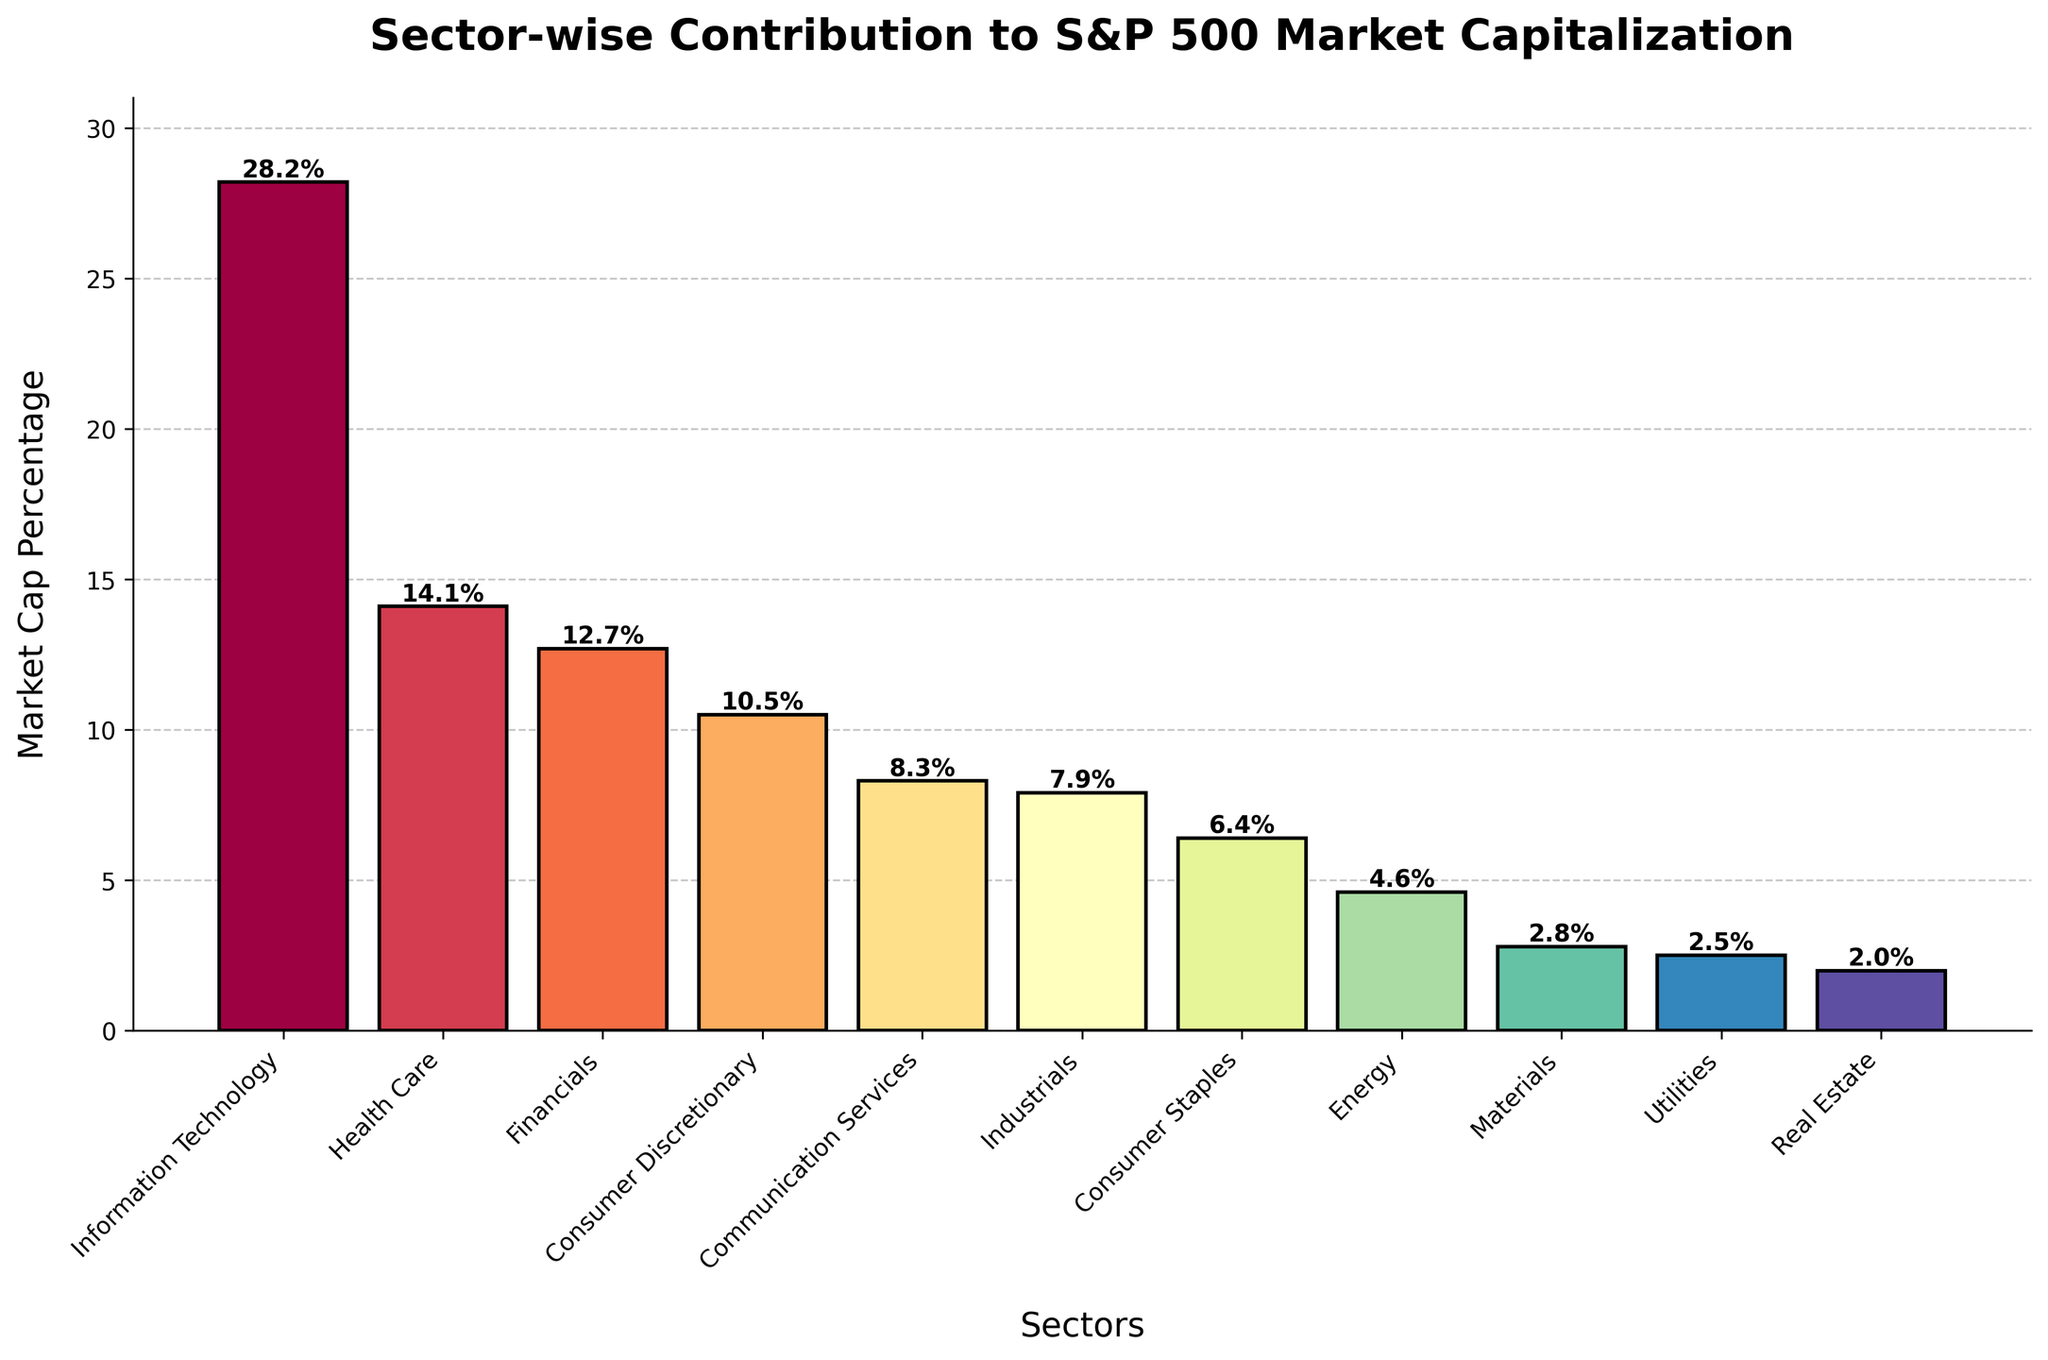Which sector has the highest contribution to S&P 500 market capitalization? By examining the height of the bars, the sector with the tallest bar is the one with the highest contribution. The Information Technology sector has the highest bar at 28.2%.
Answer: Information Technology Which sector has the lowest contribution to S&P 500 market capitalization? By identifying the shortest bar in the chart, we see that the Real Estate sector has the shortest bar at 2.0%.
Answer: Real Estate What is the combined market cap percentage of Health Care and Financials sectors? The market cap percentages of Health Care and Financials are 14.1% and 12.7%, respectively. Adding these together: 14.1 + 12.7 = 26.8%.
Answer: 26.8% How much greater is the market cap percentage of Information Technology compared to Consumer Discretionary? The market cap percentages for Information Technology and Consumer Discretionary are 28.2% and 10.5%, respectively. Subtracting these: 28.2 - 10.5 = 17.7%.
Answer: 17.7% Which sectors' combined market cap percentages equal that of the Financials sector? The Financials sector has a market cap percentage of 12.7%. Consumer Staples and Energy have percentages of 6.4% and 4.6%, respectively. Adding these together: 6.4 + 4.6 = 11%. Therefore, adding Materials' 2.8%: 11 + 2.8 = 13.8%, which is slightly more than Financials. Health Care alone is the closest at 14.1%.
Answer: Health Care What is the difference in the market cap percentages between the Communication Services and Energy sectors? The market cap percentages for Communication Services and Energy are 8.3% and 4.6%, respectively. Subtracting these: 8.3 - 4.6 = 3.7%.
Answer: 3.7% Which sector has the second-highest market cap percentage, and what is this percentage? After Information Technology, which has the highest percentage, the next tallest bar belongs to Health Care with 14.1%.
Answer: Health Care, 14.1% What is the average market cap percentage of the top three sectors? The top three sectors are Information Technology (28.2%), Health Care (14.1%), and Financials (12.7%). Adding these together: 28.2 + 14.1 + 12.7 = 55. Subtracting these: 55 / 3 ≈ 18.33%.
Answer: 18.33% How much higher is the contribution of Industrials compared to Materials? The market cap percentages for Industrials and Materials are 7.9% and 2.8%, respectively. Subtracting these: 7.9 - 2.8 = 5.1%.
Answer: 5.1% 